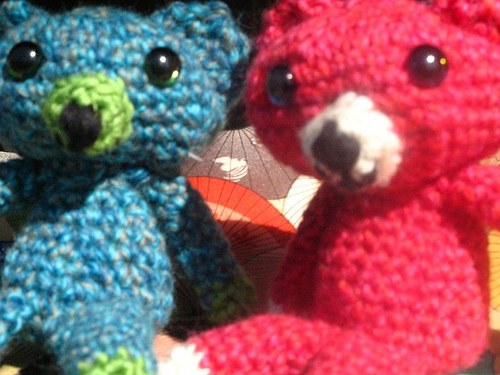<image>
Is the teddy on the teddy? No. The teddy is not positioned on the teddy. They may be near each other, but the teddy is not supported by or resting on top of the teddy. 